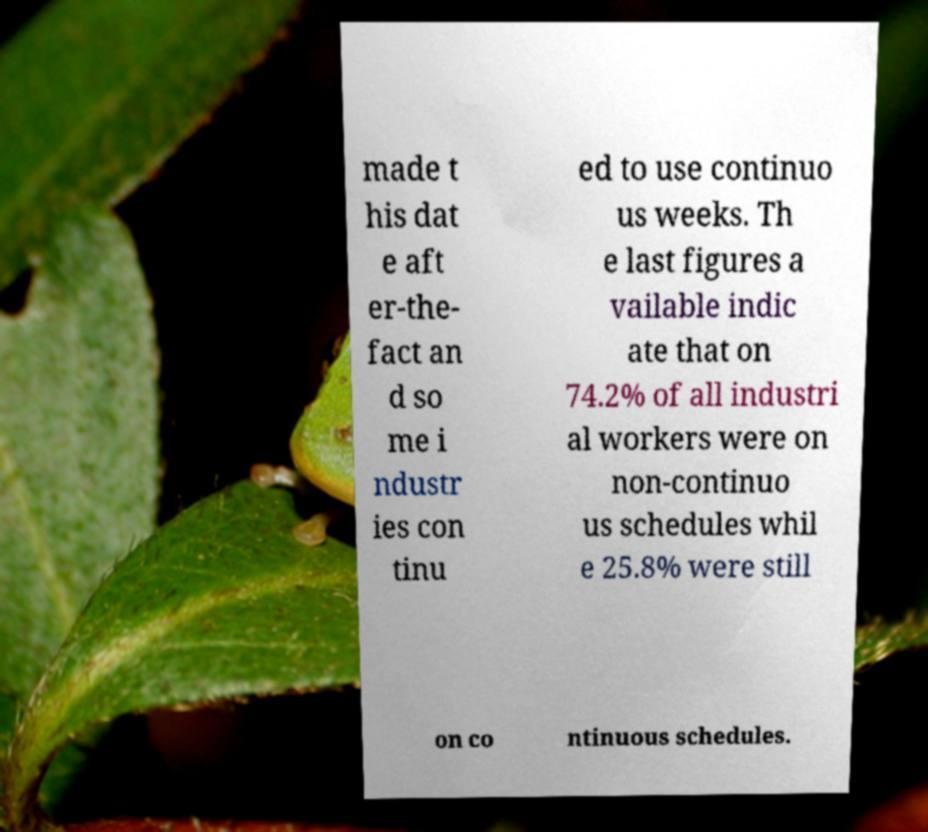For documentation purposes, I need the text within this image transcribed. Could you provide that? made t his dat e aft er-the- fact an d so me i ndustr ies con tinu ed to use continuo us weeks. Th e last figures a vailable indic ate that on 74.2% of all industri al workers were on non-continuo us schedules whil e 25.8% were still on co ntinuous schedules. 